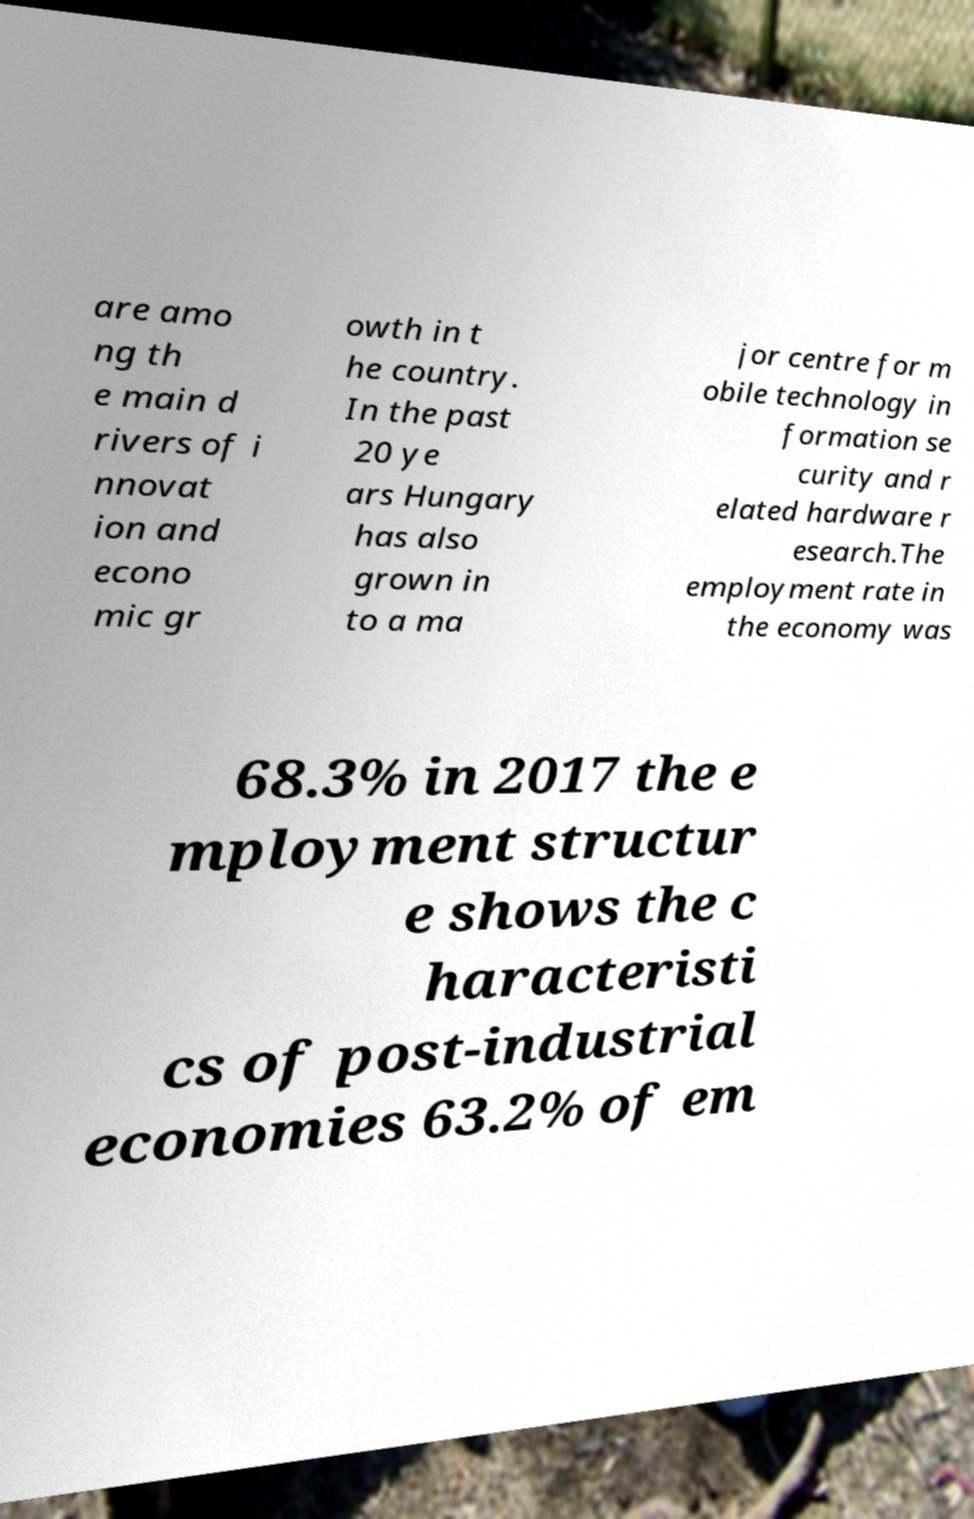Please identify and transcribe the text found in this image. are amo ng th e main d rivers of i nnovat ion and econo mic gr owth in t he country. In the past 20 ye ars Hungary has also grown in to a ma jor centre for m obile technology in formation se curity and r elated hardware r esearch.The employment rate in the economy was 68.3% in 2017 the e mployment structur e shows the c haracteristi cs of post-industrial economies 63.2% of em 